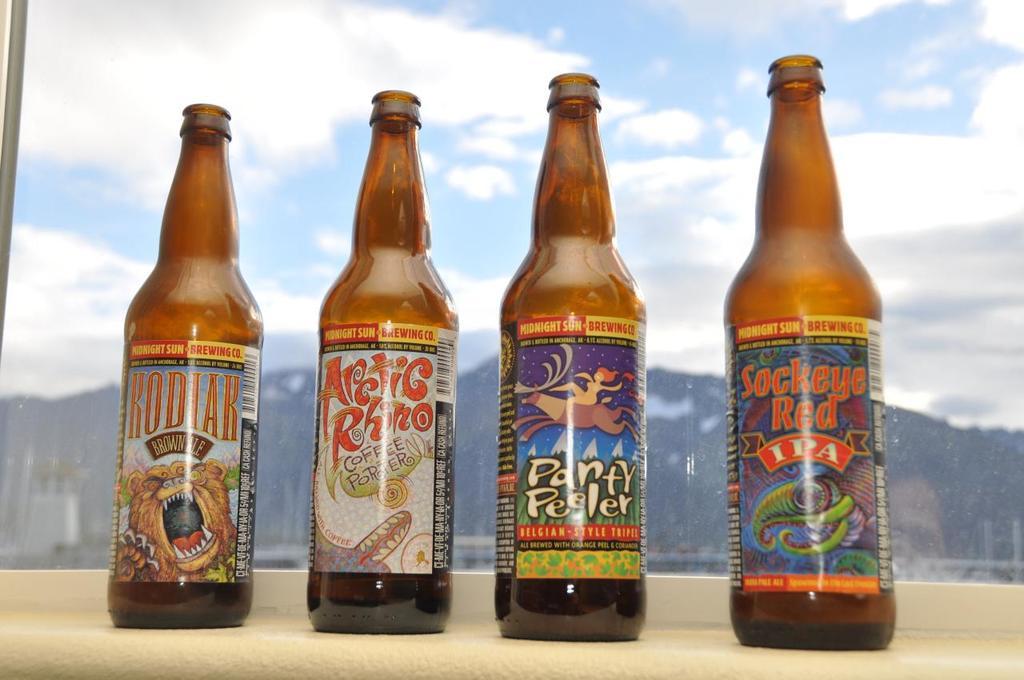What brewery makes these ipa brews?
Give a very brief answer. Midnight sun. What is the name of the drink on the far right?
Your response must be concise. Sockeye red. 